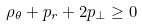<formula> <loc_0><loc_0><loc_500><loc_500>\rho _ { \theta } + p _ { r } + 2 p _ { \perp } \geq 0</formula> 